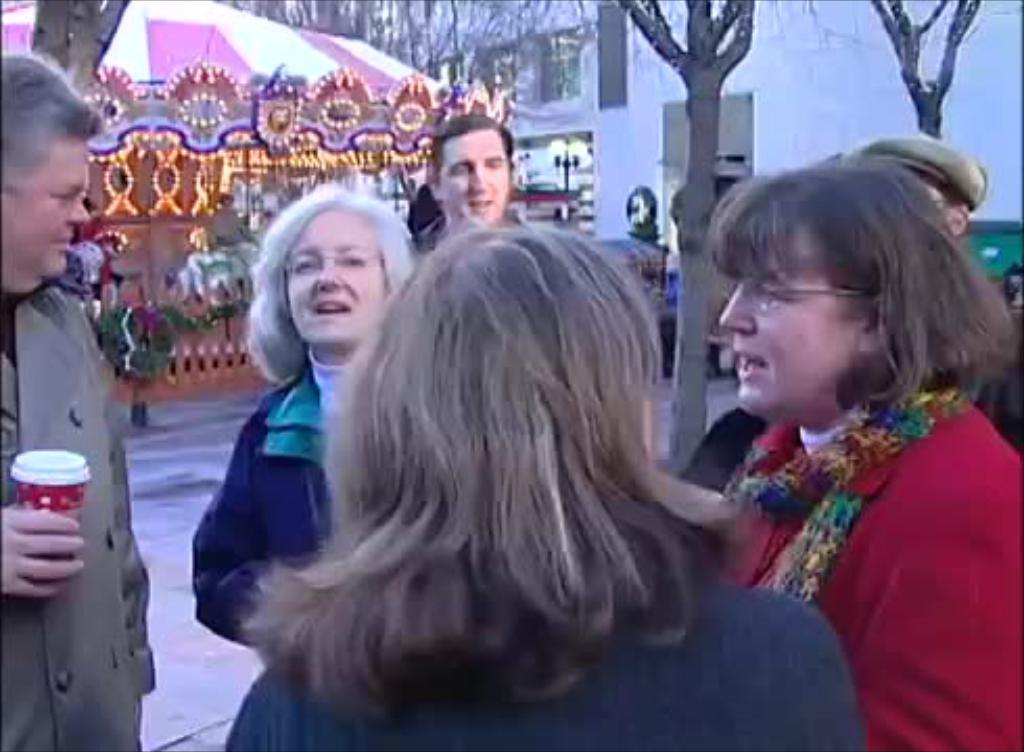In one or two sentences, can you explain what this image depicts? In this picture we can see a group of people standing on the path and a man is holding a cup. Behind the people there are trees, buildings and other things. 